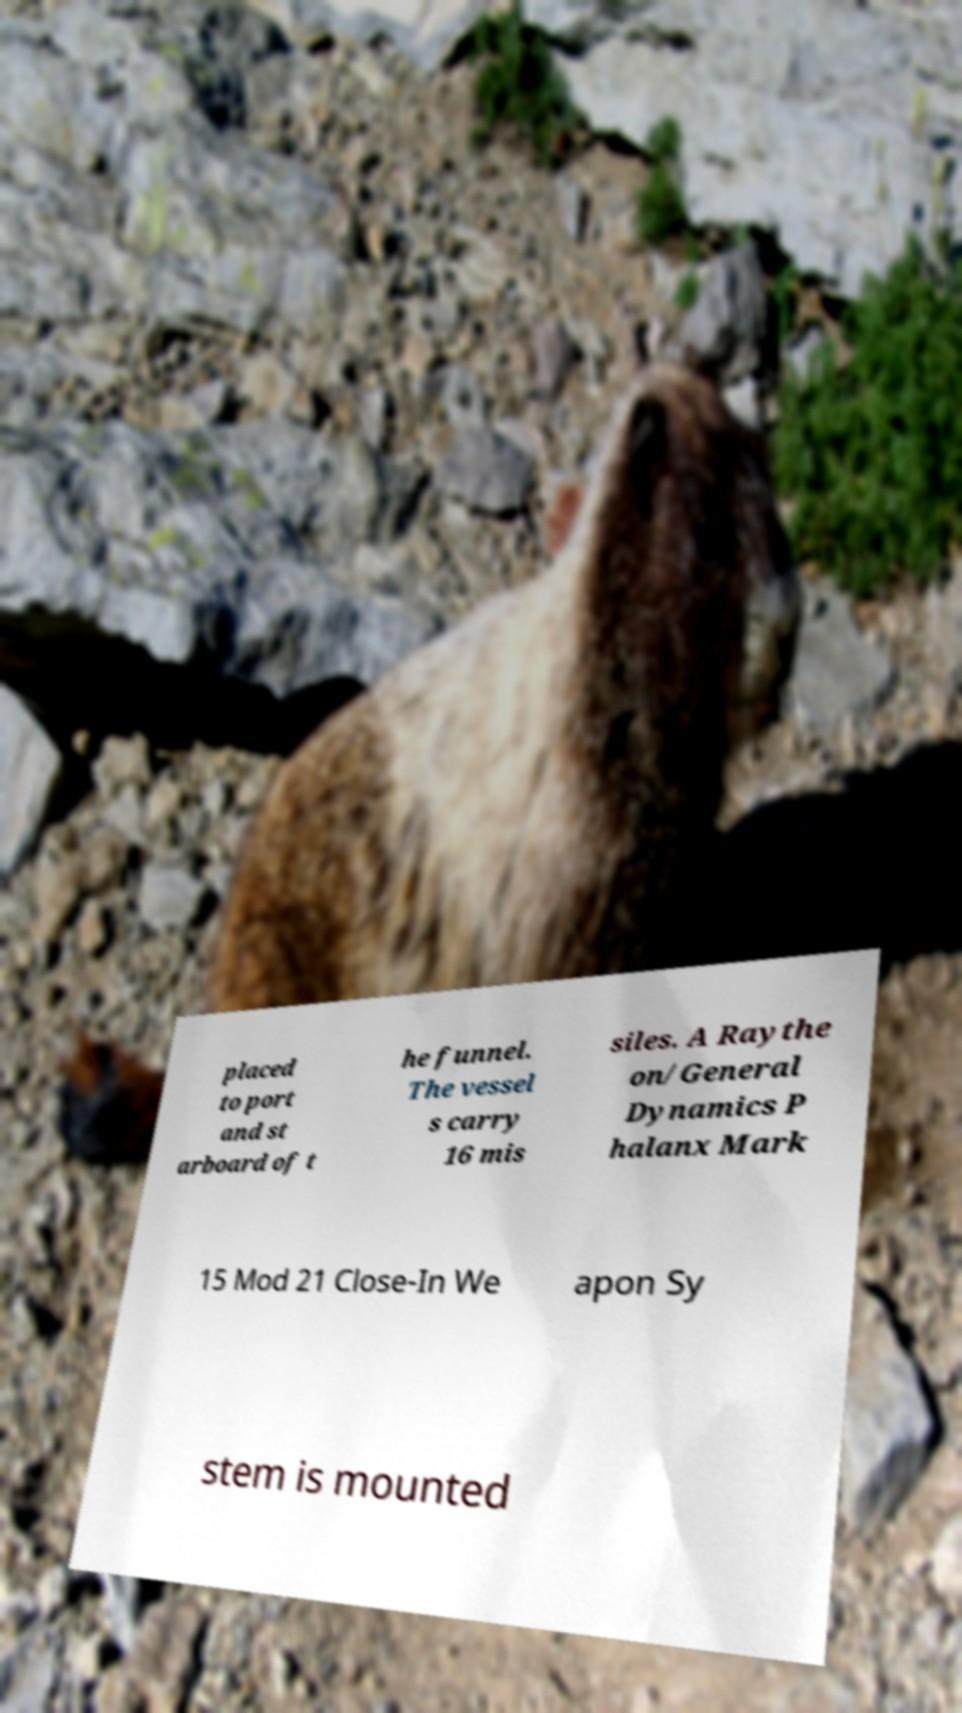For documentation purposes, I need the text within this image transcribed. Could you provide that? placed to port and st arboard of t he funnel. The vessel s carry 16 mis siles. A Raythe on/General Dynamics P halanx Mark 15 Mod 21 Close-In We apon Sy stem is mounted 